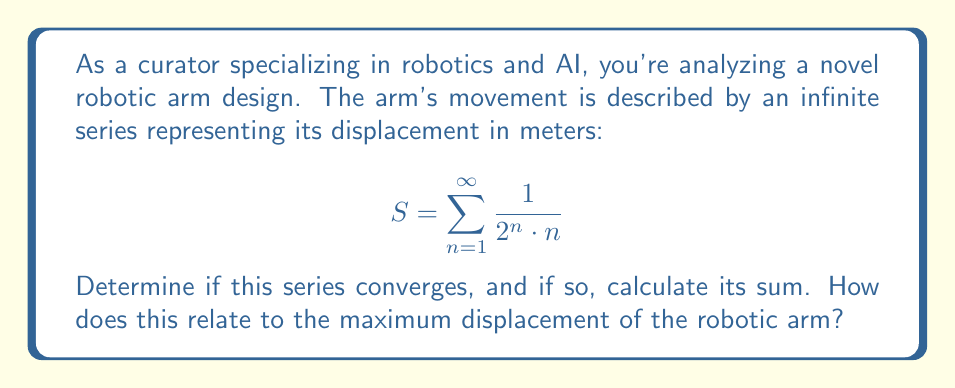What is the answer to this math problem? To determine if the series converges and calculate its sum, we'll follow these steps:

1) First, let's check for convergence using the ratio test:

   $$\lim_{n \to \infty} \left|\frac{a_{n+1}}{a_n}\right| = \lim_{n \to \infty} \left|\frac{\frac{1}{2^{n+1} \cdot (n+1)}}{\frac{1}{2^n \cdot n}}\right| = \lim_{n \to \infty} \frac{2^n \cdot n}{2^{n+1} \cdot (n+1)} = \lim_{n \to \infty} \frac{n}{2(n+1)} = \frac{1}{2}$$

   Since this limit is less than 1, the series converges.

2) To calculate the sum, we can relate this series to the Taylor series of $\ln(1+x)$:

   $$\ln(1+x) = x - \frac{x^2}{2} + \frac{x^3}{3} - \frac{x^4}{4} + ... = \sum_{n=1}^{\infty} (-1)^{n+1} \frac{x^n}{n}$$

3) Our series can be written as:

   $$S = \sum_{n=1}^{\infty} \frac{1}{2^n \cdot n} = \sum_{n=1}^{\infty} \frac{(1/2)^n}{n}$$

4) This is the same as the Taylor series for $\ln(1+x)$ with $x = 1/2$:

   $$S = \ln(1+\frac{1}{2}) = \ln(\frac{3}{2})$$

5) Therefore, the sum of the series is $\ln(\frac{3}{2})$.

In the context of the robotic arm, this means that the maximum displacement of the arm is finite and equal to $\ln(\frac{3}{2})$ meters. This implies that despite the infinite number of terms in the series, the arm's movement converges to a specific point, ensuring precise and predictable motion control.
Answer: The series converges, and its sum is $\ln(\frac{3}{2})$ meters. 